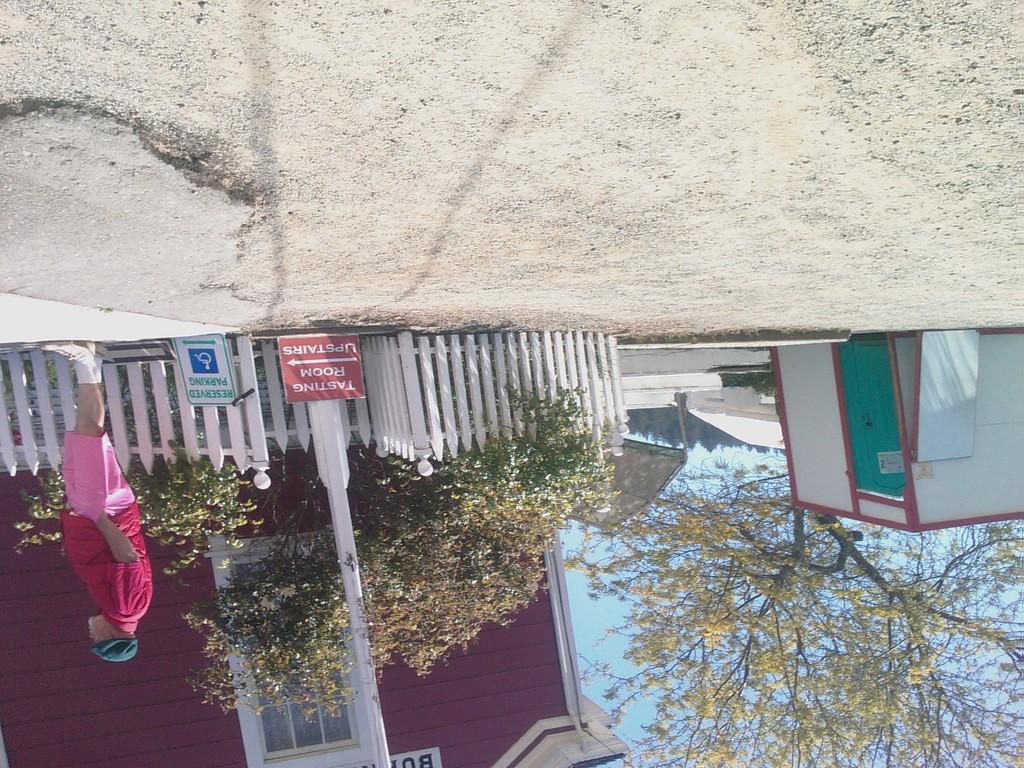How would you summarize this image in a sentence or two? In this image I can see the image is reversed where I can see the trees. I can see a person standing. I can also see some boards with some text written on it. 